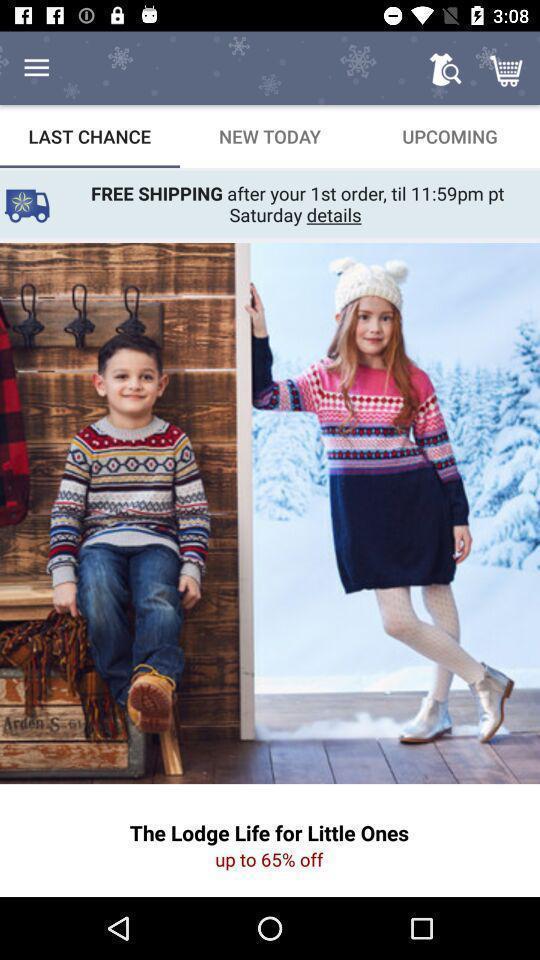Describe the key features of this screenshot. Results for last change in the shopping application. 